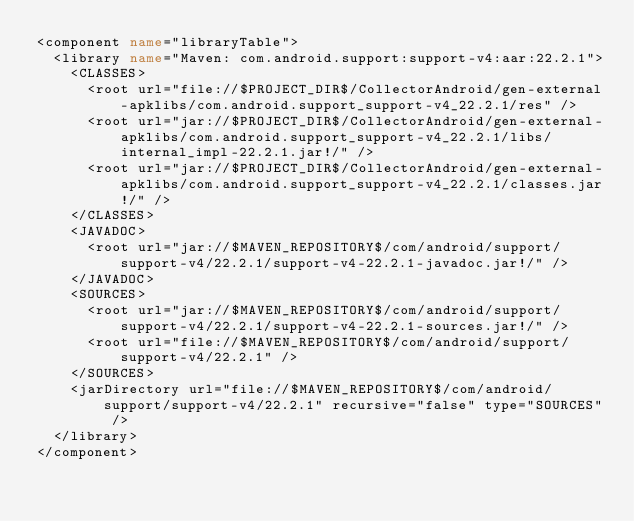<code> <loc_0><loc_0><loc_500><loc_500><_XML_><component name="libraryTable">
  <library name="Maven: com.android.support:support-v4:aar:22.2.1">
    <CLASSES>
      <root url="file://$PROJECT_DIR$/CollectorAndroid/gen-external-apklibs/com.android.support_support-v4_22.2.1/res" />
      <root url="jar://$PROJECT_DIR$/CollectorAndroid/gen-external-apklibs/com.android.support_support-v4_22.2.1/libs/internal_impl-22.2.1.jar!/" />
      <root url="jar://$PROJECT_DIR$/CollectorAndroid/gen-external-apklibs/com.android.support_support-v4_22.2.1/classes.jar!/" />
    </CLASSES>
    <JAVADOC>
      <root url="jar://$MAVEN_REPOSITORY$/com/android/support/support-v4/22.2.1/support-v4-22.2.1-javadoc.jar!/" />
    </JAVADOC>
    <SOURCES>
      <root url="jar://$MAVEN_REPOSITORY$/com/android/support/support-v4/22.2.1/support-v4-22.2.1-sources.jar!/" />
      <root url="file://$MAVEN_REPOSITORY$/com/android/support/support-v4/22.2.1" />
    </SOURCES>
    <jarDirectory url="file://$MAVEN_REPOSITORY$/com/android/support/support-v4/22.2.1" recursive="false" type="SOURCES" />
  </library>
</component></code> 